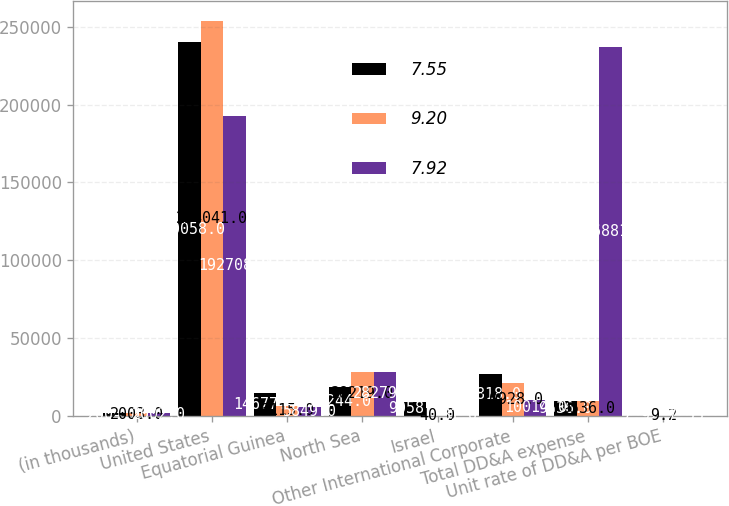Convert chart to OTSL. <chart><loc_0><loc_0><loc_500><loc_500><stacked_bar_chart><ecel><fcel>(in thousands)<fcel>United States<fcel>Equatorial Guinea<fcel>North Sea<fcel>Israel<fcel>Other International Corporate<fcel>Total DD&A expense<fcel>Unit rate of DD&A per BOE<nl><fcel>7.55<fcel>2004<fcel>240058<fcel>14677<fcel>18244<fcel>9058<fcel>26818<fcel>9536<fcel>7.92<nl><fcel>9.2<fcel>2003<fcel>254041<fcel>6115<fcel>28219<fcel>40<fcel>20928<fcel>9536<fcel>9.2<nl><fcel>7.92<fcel>2002<fcel>192708<fcel>5849<fcel>28279<fcel>31<fcel>10014<fcel>236881<fcel>7.55<nl></chart> 